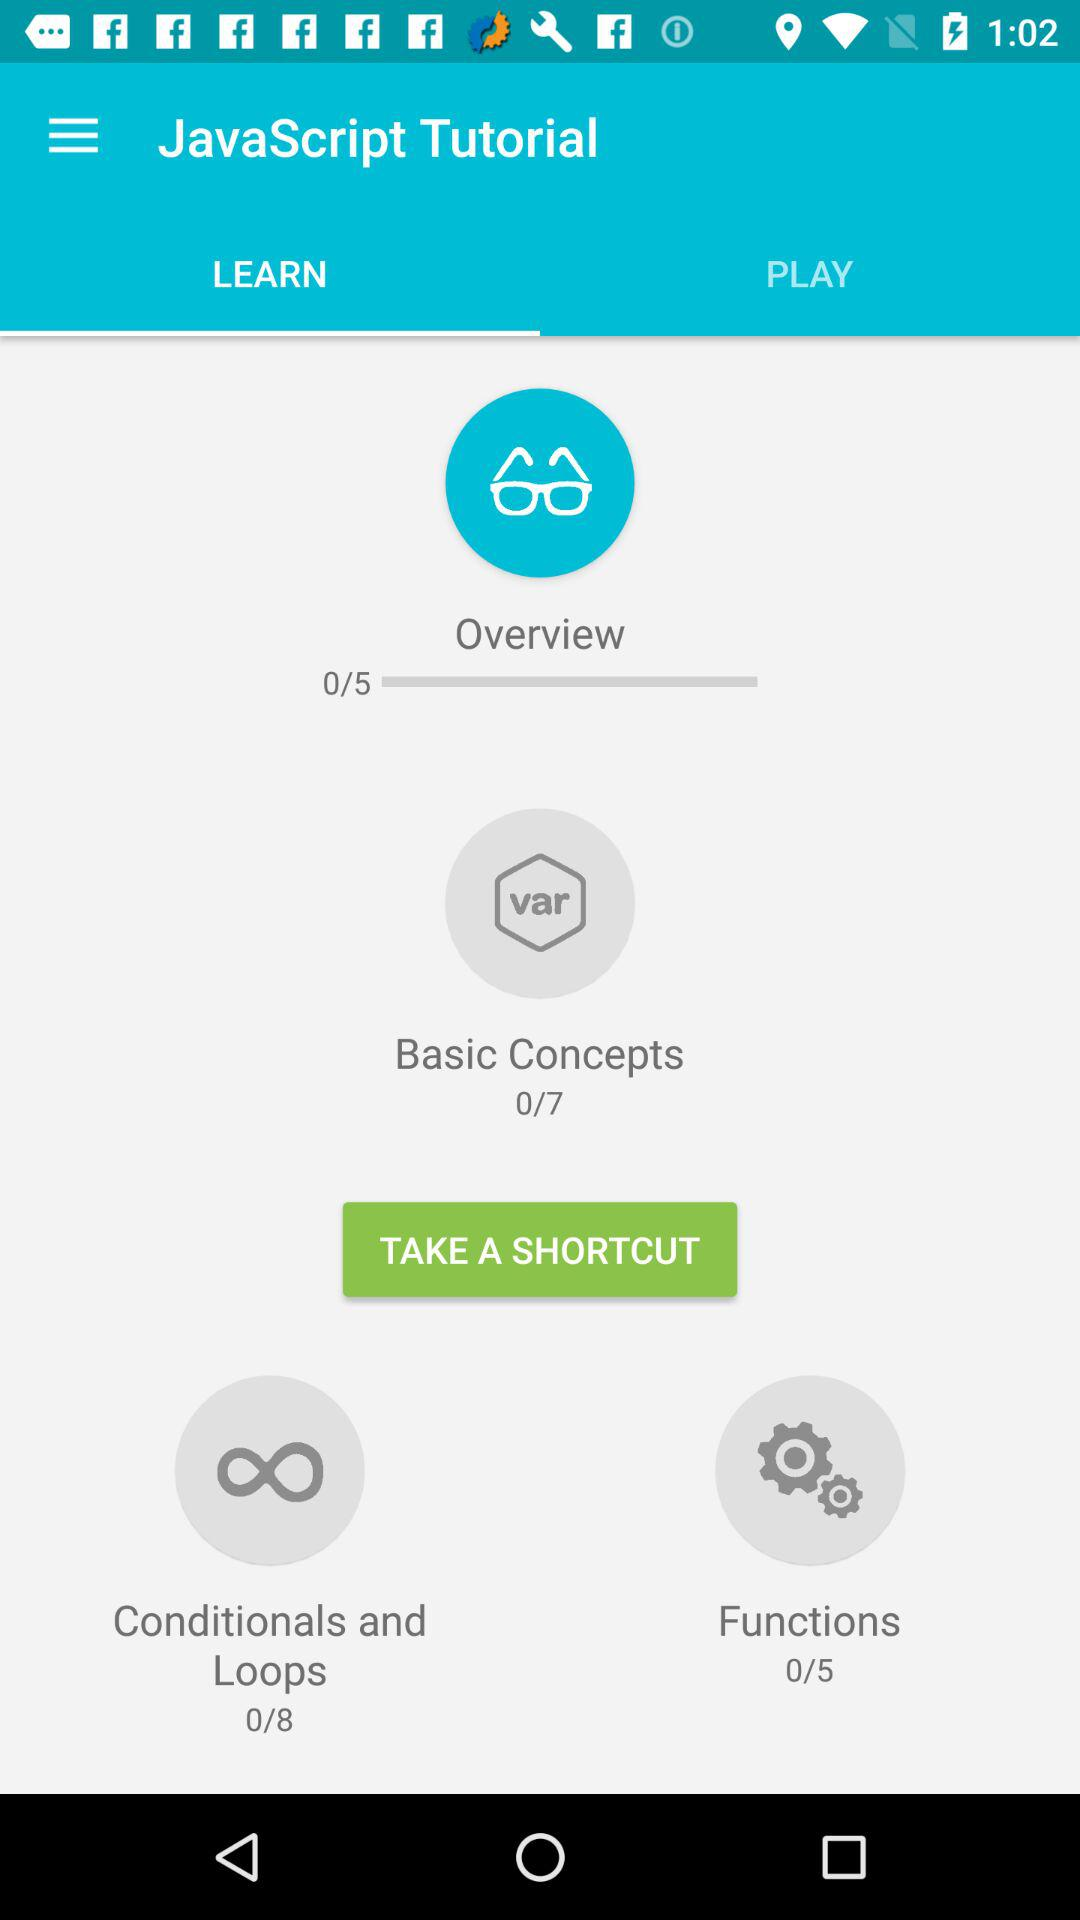What is the total number of lessons in the "Functions" topic? The total number of lessons in the "Functions" topic is 5. 